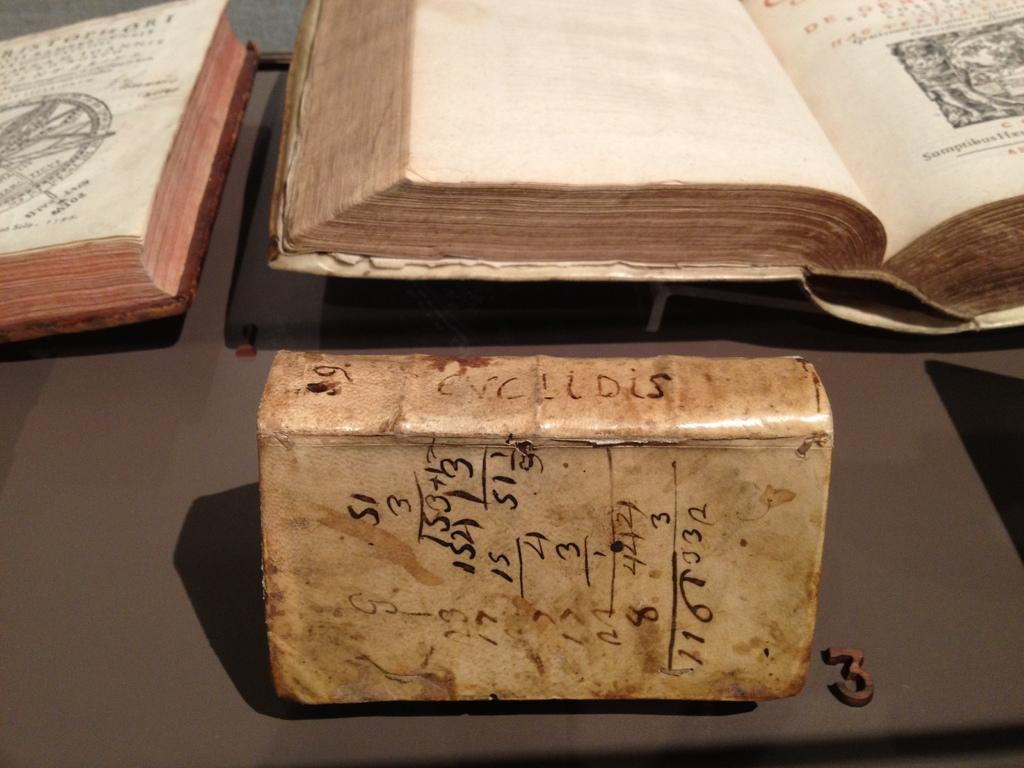<image>
Offer a succinct explanation of the picture presented. A little block with hand-written math all over it is labeled number 3 on the table. 